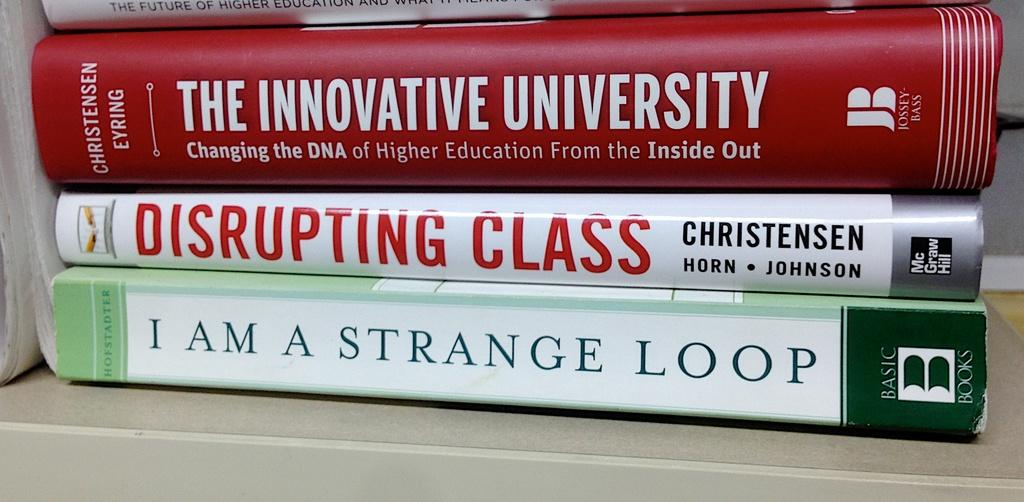Provide a one-sentence caption for the provided image. The book "I am a Strange Loop" sits at the bottom of a stack of books. 